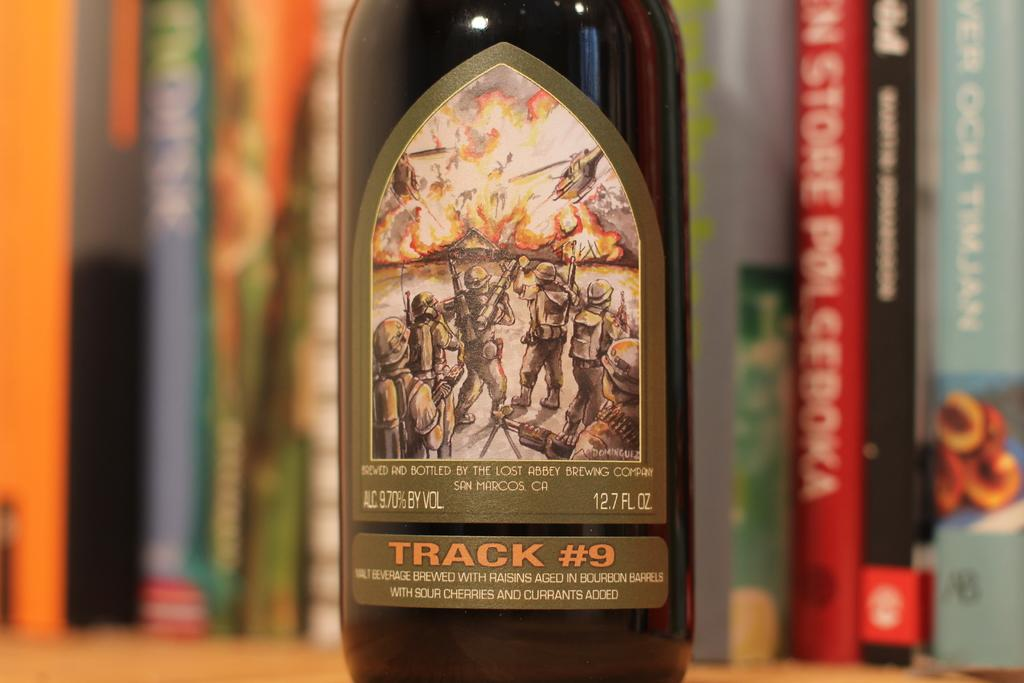<image>
Create a compact narrative representing the image presented. Bottle of beer with the word "Track #9" near the bottom in front of some books. 